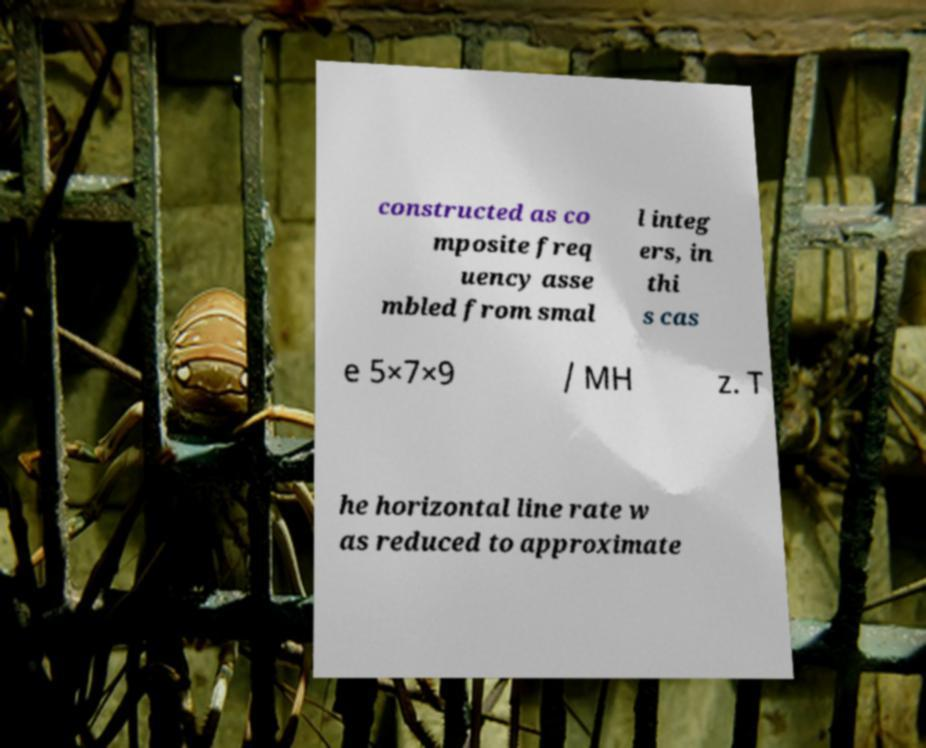For documentation purposes, I need the text within this image transcribed. Could you provide that? constructed as co mposite freq uency asse mbled from smal l integ ers, in thi s cas e 5×7×9 / MH z. T he horizontal line rate w as reduced to approximate 